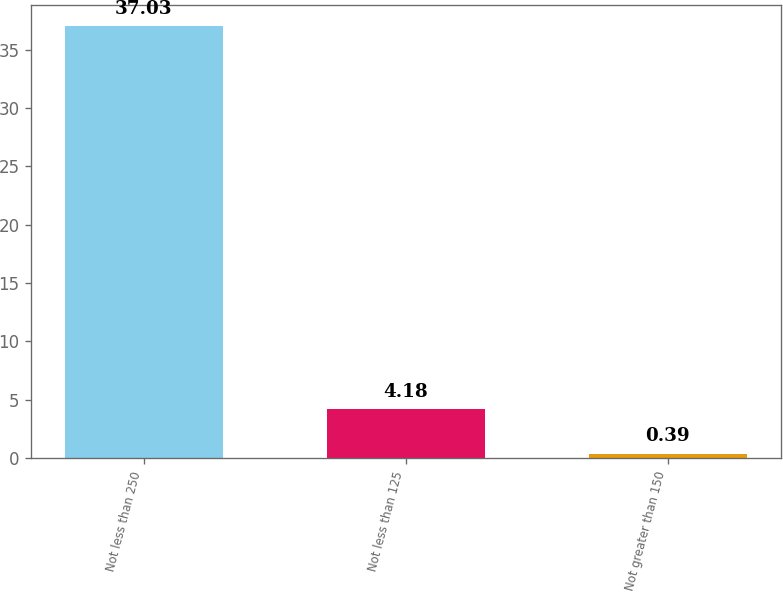Convert chart. <chart><loc_0><loc_0><loc_500><loc_500><bar_chart><fcel>Not less than 250<fcel>Not less than 125<fcel>Not greater than 150<nl><fcel>37.03<fcel>4.18<fcel>0.39<nl></chart> 